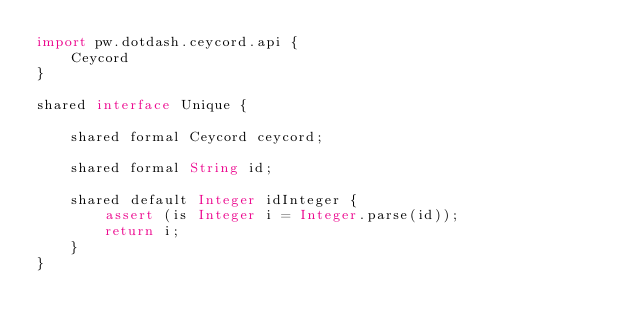<code> <loc_0><loc_0><loc_500><loc_500><_Ceylon_>import pw.dotdash.ceycord.api {
    Ceycord
}

shared interface Unique {

    shared formal Ceycord ceycord;

    shared formal String id;

    shared default Integer idInteger {
        assert (is Integer i = Integer.parse(id));
        return i;
    }
}</code> 